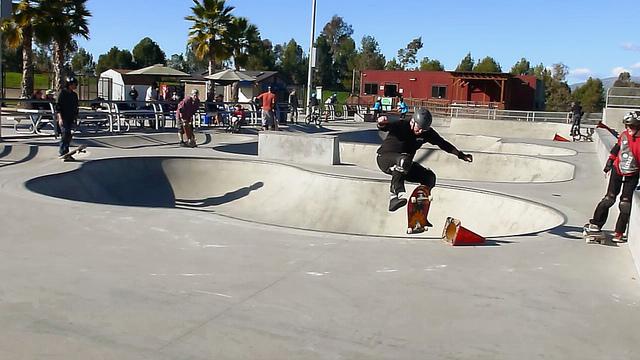How many people are skateboarding?
Give a very brief answer. 1. Is the skateboarder doing down?
Answer briefly. No. How many windows are on the red building in the background?
Short answer required. 3. 